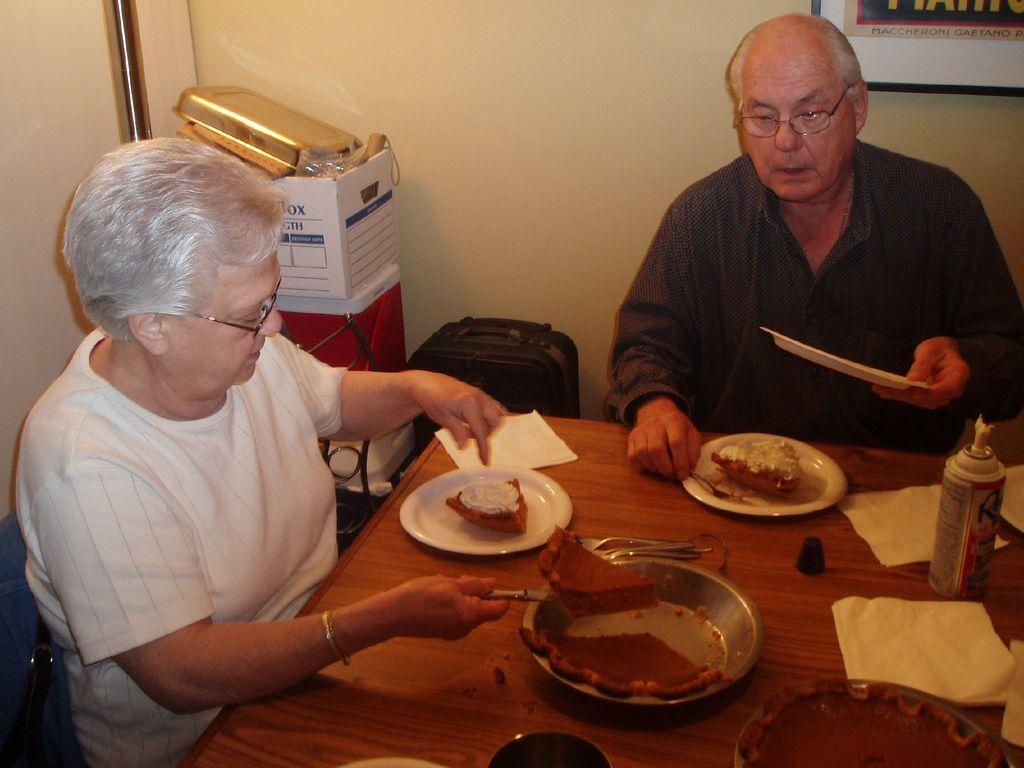Could you give a brief overview of what you see in this image? In this image we can see two people sitting on chairs. In front of them there is a table on which there are food items in plates and there are tissues. In the background of the image there is wall. There is a photo frame. There are other objects. 